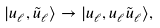Convert formula to latex. <formula><loc_0><loc_0><loc_500><loc_500>| u _ { \ell } , \tilde { u } _ { \ell } \rangle \to | u _ { \ell } , u _ { \ell } \tilde { u } _ { \ell } \rangle ,</formula> 